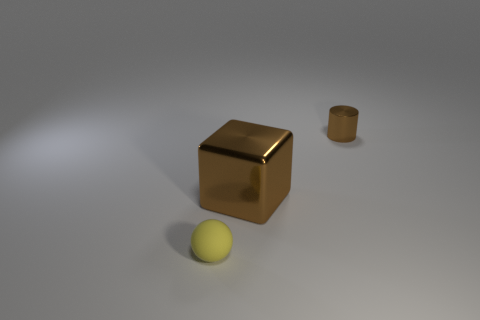Add 1 small rubber balls. How many objects exist? 4 Subtract 0 gray balls. How many objects are left? 3 Subtract all balls. How many objects are left? 2 Subtract 1 cylinders. How many cylinders are left? 0 Subtract all gray cylinders. Subtract all cyan balls. How many cylinders are left? 1 Subtract all yellow cylinders. How many gray cubes are left? 0 Subtract all purple rubber things. Subtract all small brown metal cylinders. How many objects are left? 2 Add 2 big brown cubes. How many big brown cubes are left? 3 Add 2 metallic blocks. How many metallic blocks exist? 3 